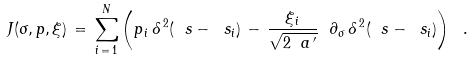<formula> <loc_0><loc_0><loc_500><loc_500>J ( \sigma , p , \xi ) \, = \, \sum _ { i \, = \, 1 } ^ { N } \left ( p _ { \, i } \, \delta ^ { \, 2 } ( \ s - \ s _ { i } ) \, - \, \frac { { \xi } _ { \, i } } { \sqrt { 2 \ a ^ { \, \prime } } } \ \partial _ { \sigma } \, \delta ^ { \, 2 } ( \ s - \ s _ { i } ) \right ) \ .</formula> 